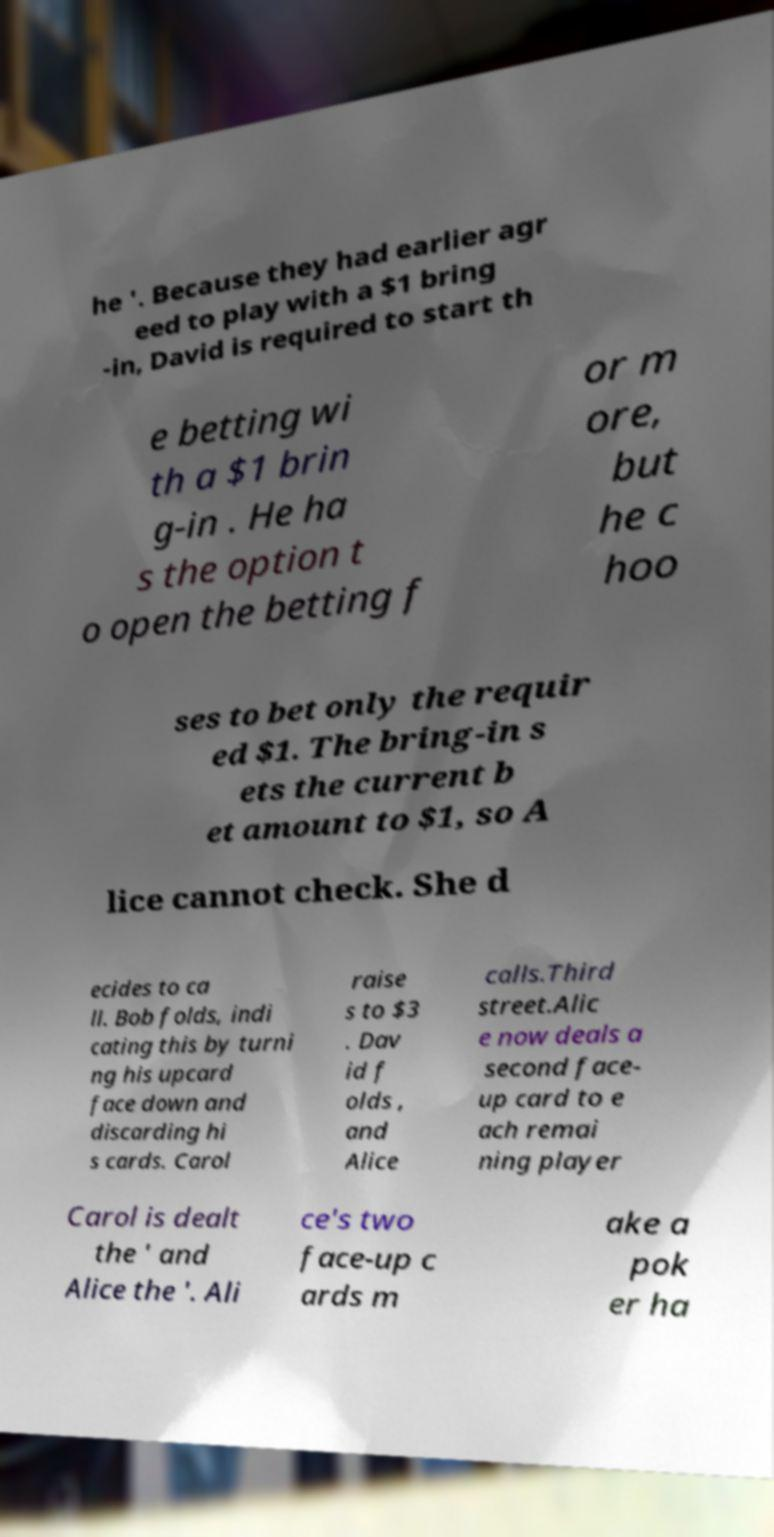Could you extract and type out the text from this image? he '. Because they had earlier agr eed to play with a $1 bring -in, David is required to start th e betting wi th a $1 brin g-in . He ha s the option t o open the betting f or m ore, but he c hoo ses to bet only the requir ed $1. The bring-in s ets the current b et amount to $1, so A lice cannot check. She d ecides to ca ll. Bob folds, indi cating this by turni ng his upcard face down and discarding hi s cards. Carol raise s to $3 . Dav id f olds , and Alice calls.Third street.Alic e now deals a second face- up card to e ach remai ning player Carol is dealt the ' and Alice the '. Ali ce's two face-up c ards m ake a pok er ha 